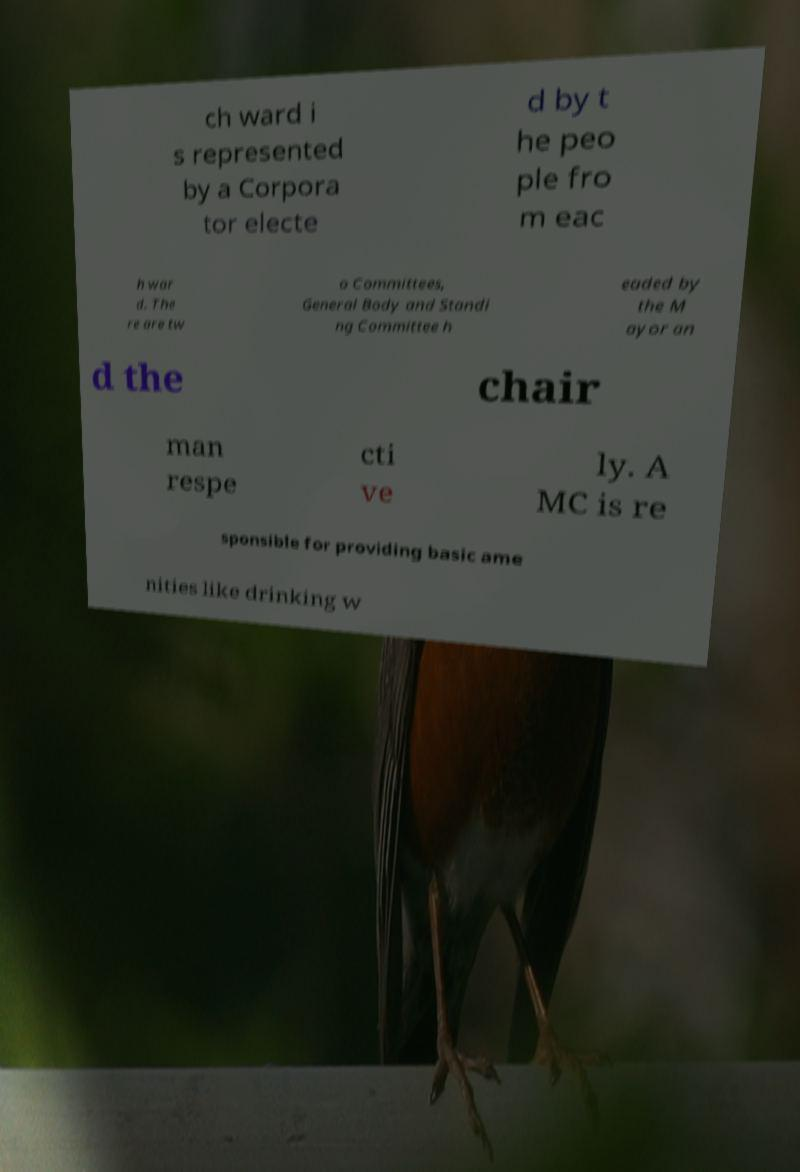Could you extract and type out the text from this image? ch ward i s represented by a Corpora tor electe d by t he peo ple fro m eac h war d. The re are tw o Committees, General Body and Standi ng Committee h eaded by the M ayor an d the chair man respe cti ve ly. A MC is re sponsible for providing basic ame nities like drinking w 